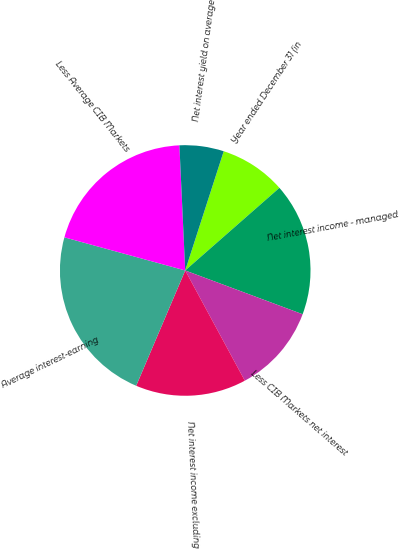<chart> <loc_0><loc_0><loc_500><loc_500><pie_chart><fcel>Year ended December 31 (in<fcel>Net interest income - managed<fcel>Less CIB Markets net interest<fcel>Net interest income excluding<fcel>Average interest-earning<fcel>Less Average CIB Markets<fcel>Net interest yield on average<nl><fcel>8.57%<fcel>17.14%<fcel>11.43%<fcel>14.29%<fcel>22.86%<fcel>20.0%<fcel>5.71%<nl></chart> 